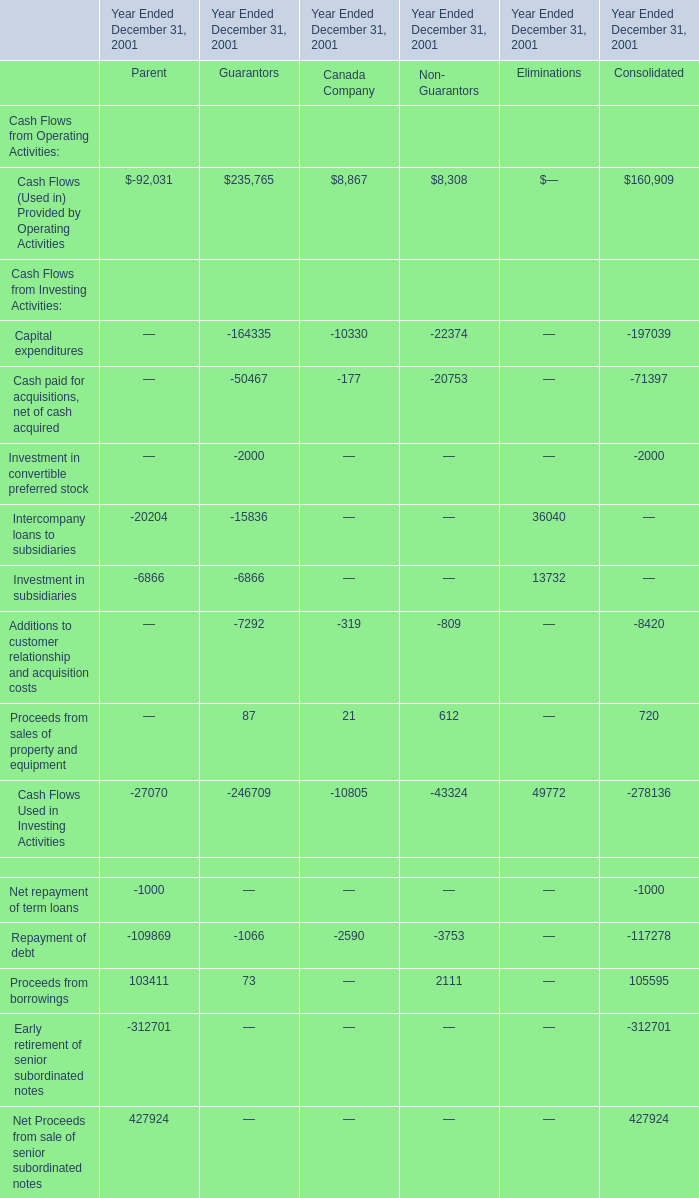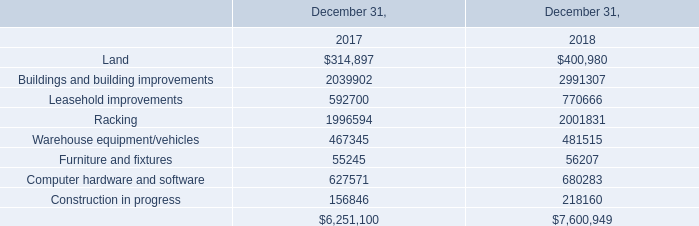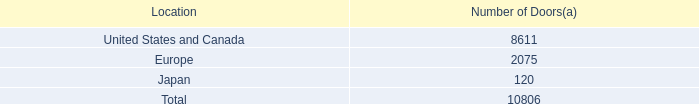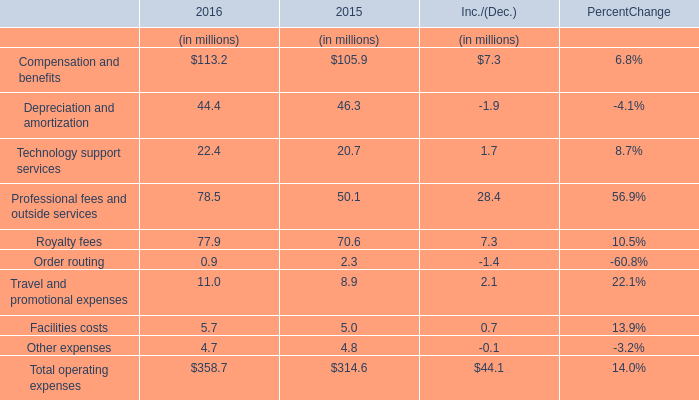What is the total amount of Land of December 31, 2018, Europe of Number of Doors, and Buildings and building improvements of December 31, 2017 ? 
Computations: ((400980.0 + 2075.0) + 2039902.0)
Answer: 2442957.0. 